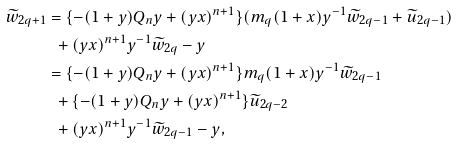Convert formula to latex. <formula><loc_0><loc_0><loc_500><loc_500>\widetilde { w } _ { 2 q + 1 } & = \{ - ( 1 + y ) Q _ { n } y + ( y x ) ^ { n + 1 } \} ( m _ { q } ( 1 + x ) y ^ { - 1 } \widetilde { w } _ { 2 q - 1 } + \widetilde { u } _ { 2 q - 1 } ) \\ & \ \ + ( y x ) ^ { n + 1 } y ^ { - 1 } \widetilde { w } _ { 2 q } - y \\ & = \{ - ( 1 + y ) Q _ { n } y + ( y x ) ^ { n + 1 } \} m _ { q } ( 1 + x ) y ^ { - 1 } \widetilde { w } _ { 2 q - 1 } \\ & \ \ + \{ - ( 1 + y ) Q _ { n } y + ( y x ) ^ { n + 1 } \} \widetilde { u } _ { 2 q - 2 } \\ & \ \ + ( y x ) ^ { n + 1 } y ^ { - 1 } \widetilde { w } _ { 2 q - 1 } - y ,</formula> 